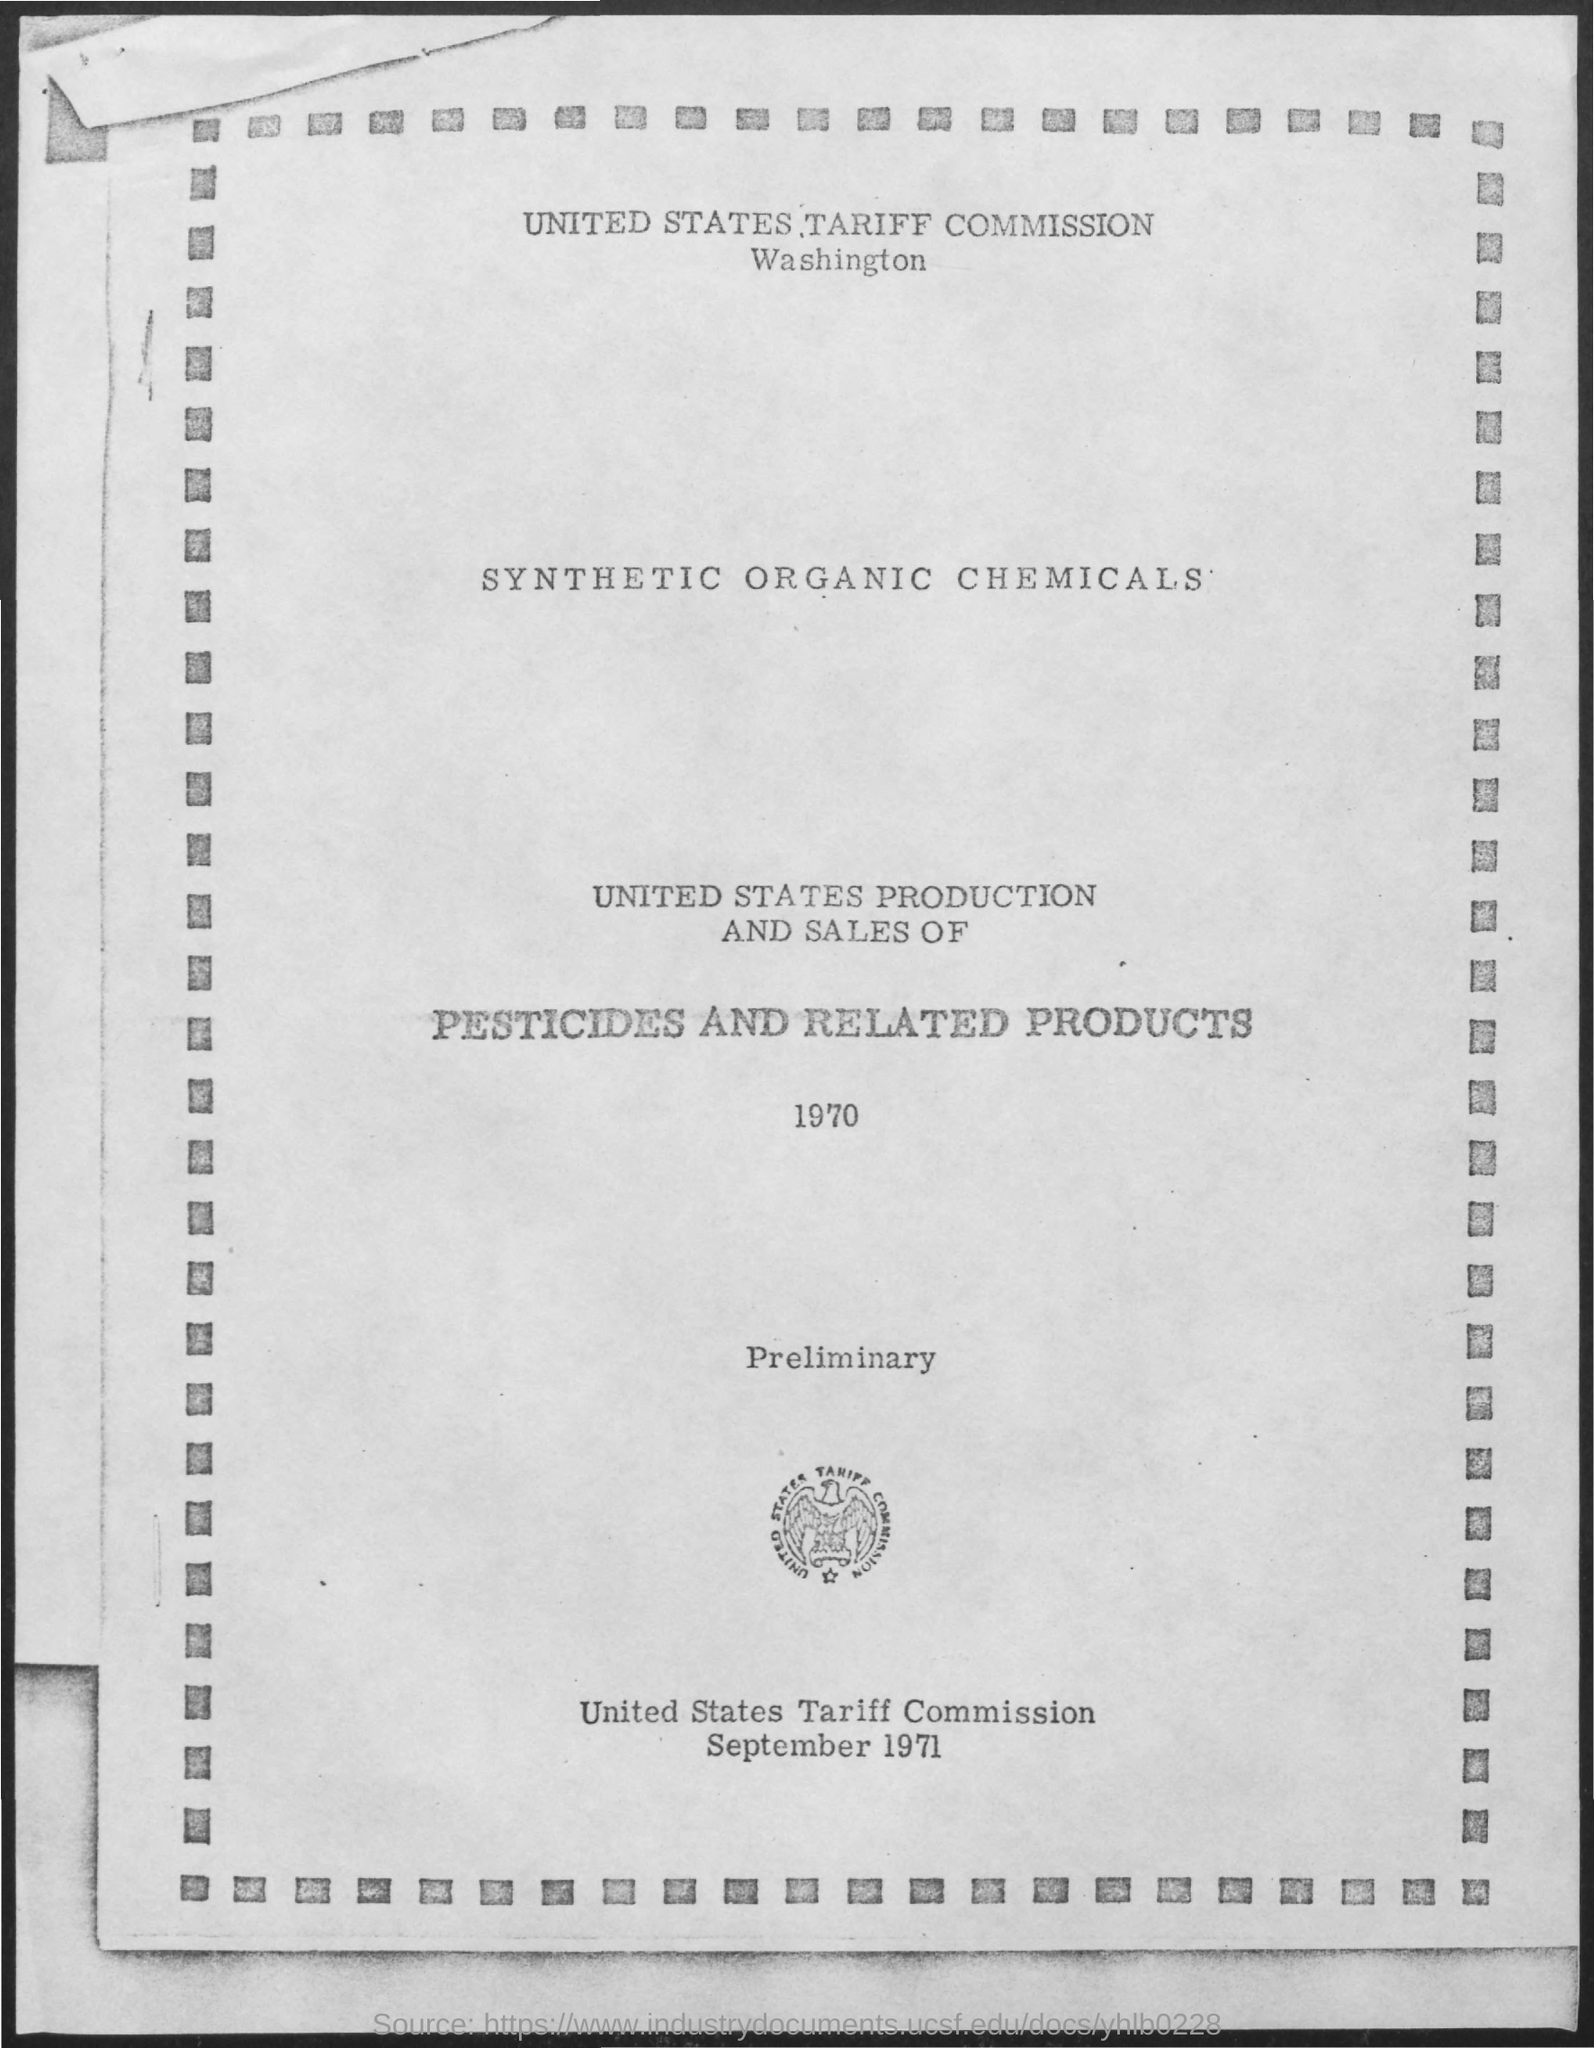What is the name of the commission mentioned ?
Ensure brevity in your answer.  United States Tariff Commission. What is the date mentioned ?
Make the answer very short. September 1971. 